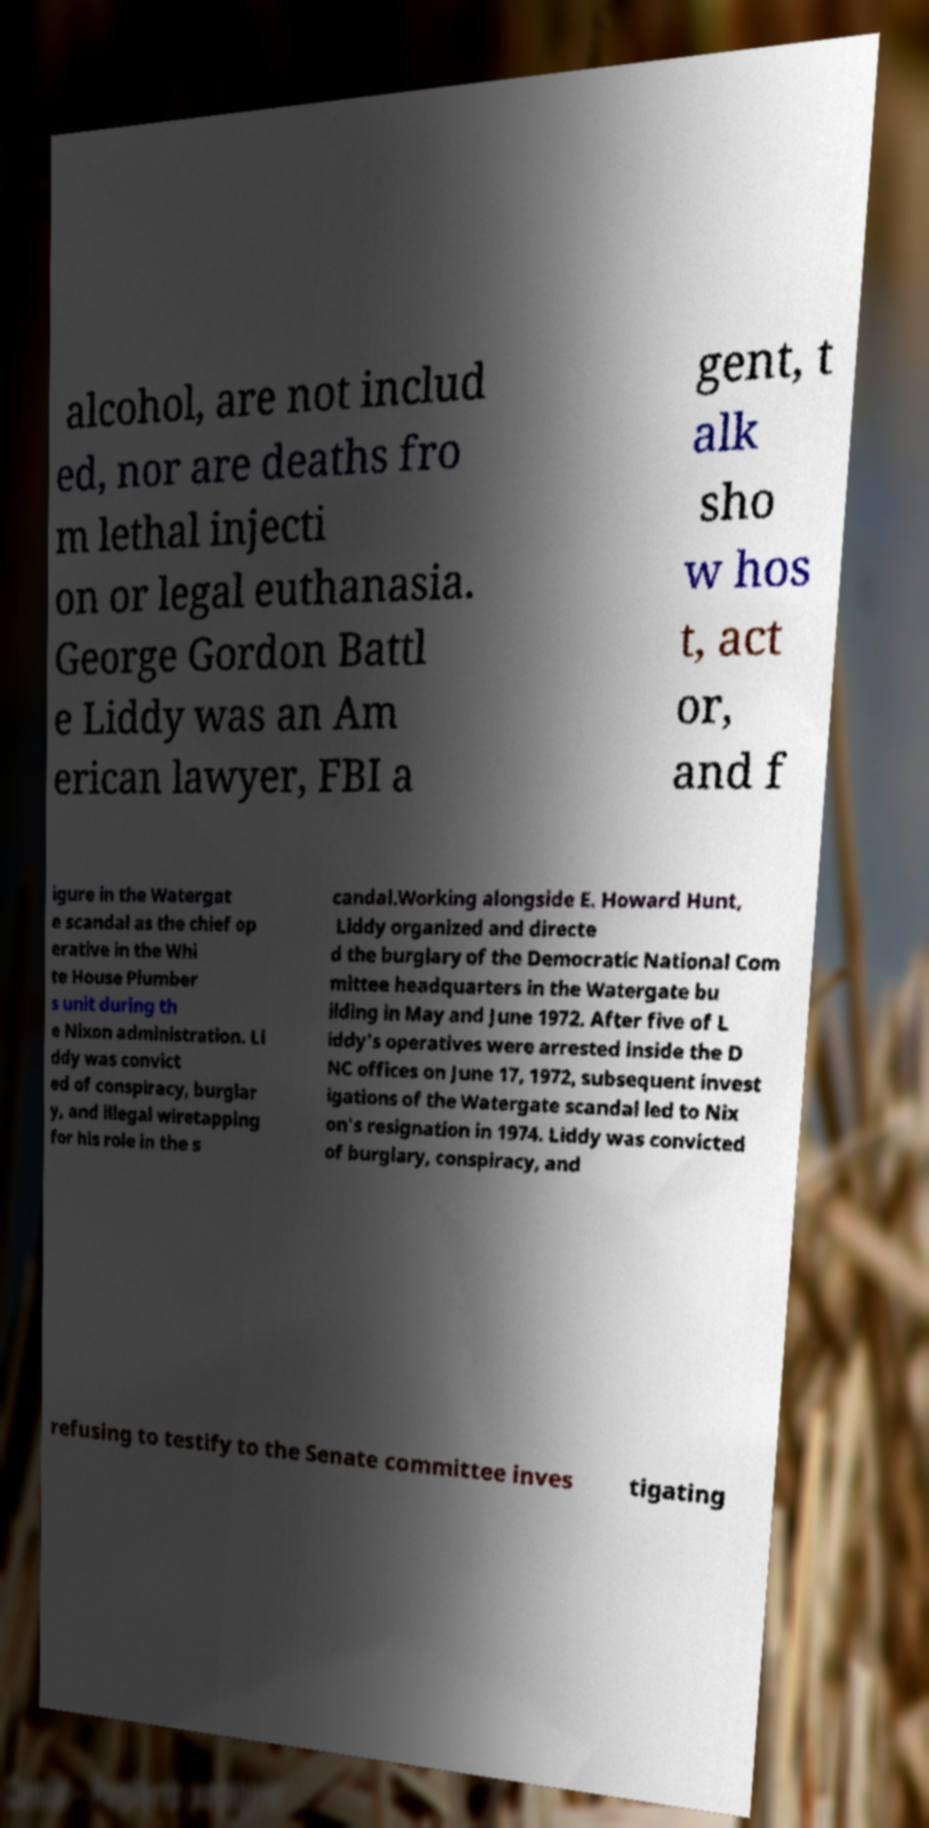There's text embedded in this image that I need extracted. Can you transcribe it verbatim? alcohol, are not includ ed, nor are deaths fro m lethal injecti on or legal euthanasia. George Gordon Battl e Liddy was an Am erican lawyer, FBI a gent, t alk sho w hos t, act or, and f igure in the Watergat e scandal as the chief op erative in the Whi te House Plumber s unit during th e Nixon administration. Li ddy was convict ed of conspiracy, burglar y, and illegal wiretapping for his role in the s candal.Working alongside E. Howard Hunt, Liddy organized and directe d the burglary of the Democratic National Com mittee headquarters in the Watergate bu ilding in May and June 1972. After five of L iddy's operatives were arrested inside the D NC offices on June 17, 1972, subsequent invest igations of the Watergate scandal led to Nix on's resignation in 1974. Liddy was convicted of burglary, conspiracy, and refusing to testify to the Senate committee inves tigating 